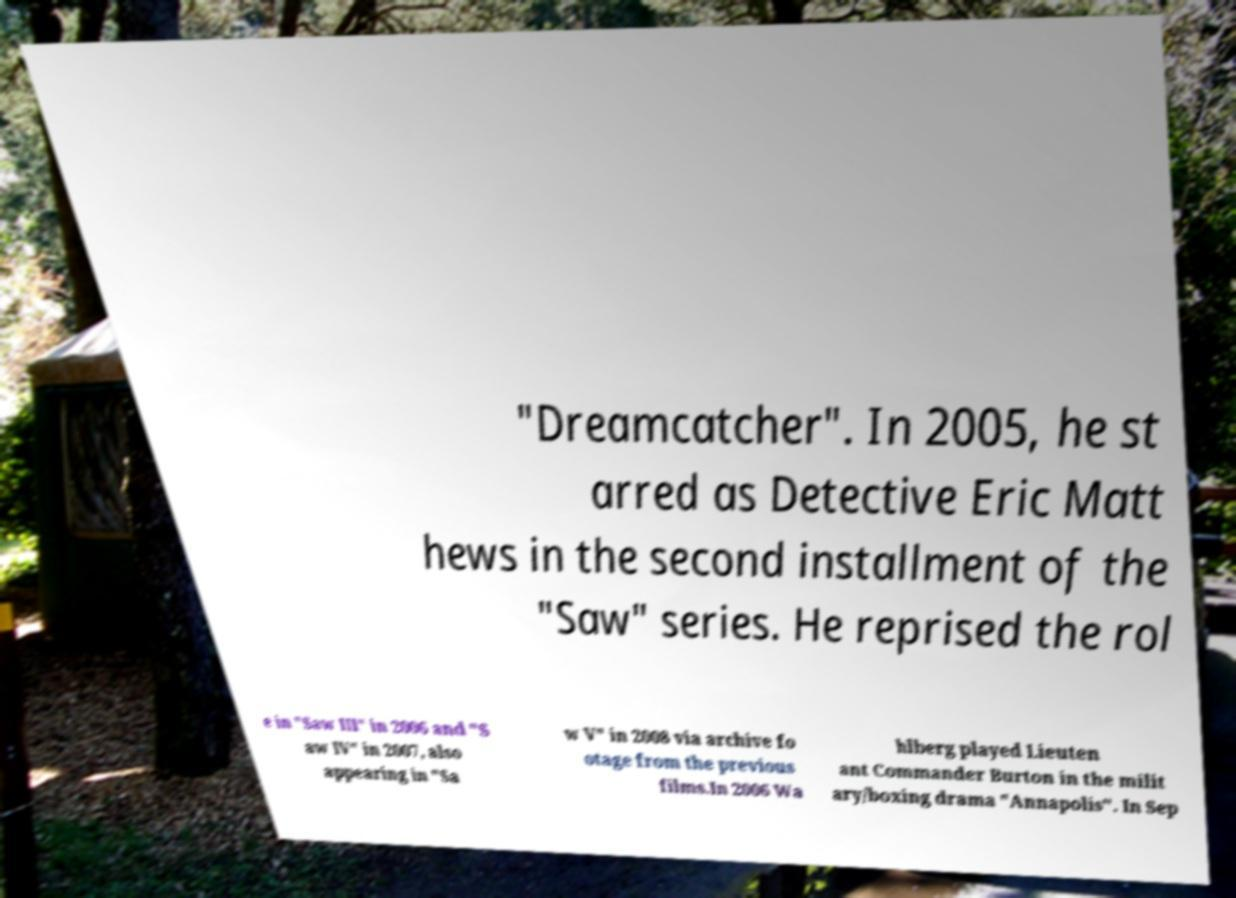For documentation purposes, I need the text within this image transcribed. Could you provide that? "Dreamcatcher". In 2005, he st arred as Detective Eric Matt hews in the second installment of the "Saw" series. He reprised the rol e in "Saw III" in 2006 and "S aw IV" in 2007, also appearing in "Sa w V" in 2008 via archive fo otage from the previous films.In 2006 Wa hlberg played Lieuten ant Commander Burton in the milit ary/boxing drama "Annapolis". In Sep 